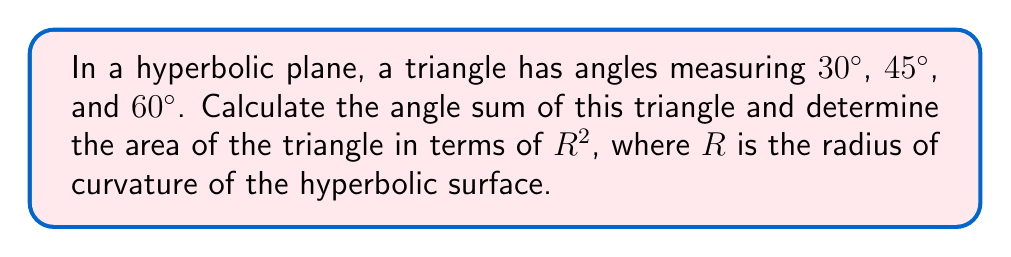Could you help me with this problem? 1) In hyperbolic geometry, the angle sum of a triangle is always less than 180°. The difference between 180° and the angle sum is called the angle defect.

2) Let's calculate the angle sum:
   $30° + 45° + 60° = 135°$

3) The angle defect is:
   $180° - 135° = 45°$

4) In hyperbolic geometry, the area of a triangle is directly related to its angle defect. The formula is:

   $$A = (π - (α + β + γ))R^2$$

   Where $A$ is the area, $α$, $β$, and $γ$ are the angles in radians, and $R$ is the radius of curvature.

5) Convert the angle defect to radians:
   $45° = \frac{45 * π}{180} = \frac{π}{4}$ radians

6) Therefore, the area of the triangle is:

   $$A = \frac{π}{4}R^2$$

This result shows that in hyperbolic geometry, unlike in Euclidean geometry, the area of a triangle is determined by its angles, not its side lengths. This concept could be related to strategic planning in coaching, where the "angles" of approach (strategies) determine the "area" of success.
Answer: Angle sum: 135°; Area: $\frac{π}{4}R^2$ 